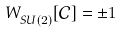Convert formula to latex. <formula><loc_0><loc_0><loc_500><loc_500>W ^ { \ } _ { S U ( 2 ) } [ \mathcal { C } ] = \pm 1</formula> 